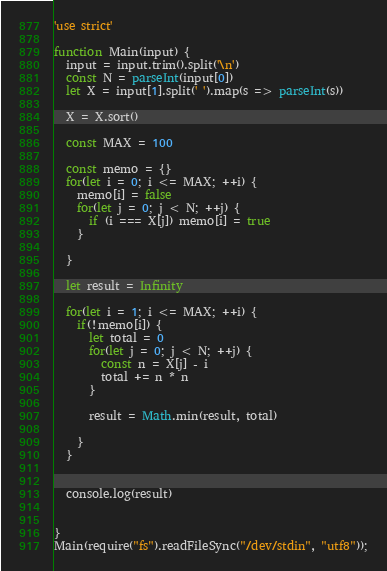Convert code to text. <code><loc_0><loc_0><loc_500><loc_500><_JavaScript_>'use strict'

function Main(input) {
  input = input.trim().split('\n')
  const N = parseInt(input[0])
  let X = input[1].split(' ').map(s => parseInt(s))

  X = X.sort()

  const MAX = 100

  const memo = {}
  for(let i = 0; i <= MAX; ++i) {
    memo[i] = false
    for(let j = 0; j < N; ++j) {
      if (i === X[j]) memo[i] = true
    }

  }

  let result = Infinity

  for(let i = 1; i <= MAX; ++i) {
    if(!memo[i]) {
      let total = 0
      for(let j = 0; j < N; ++j) {
        const n = X[j] - i
        total += n * n
      }

      result = Math.min(result, total)

    }
  }


  console.log(result)


}
Main(require("fs").readFileSync("/dev/stdin", "utf8"));</code> 